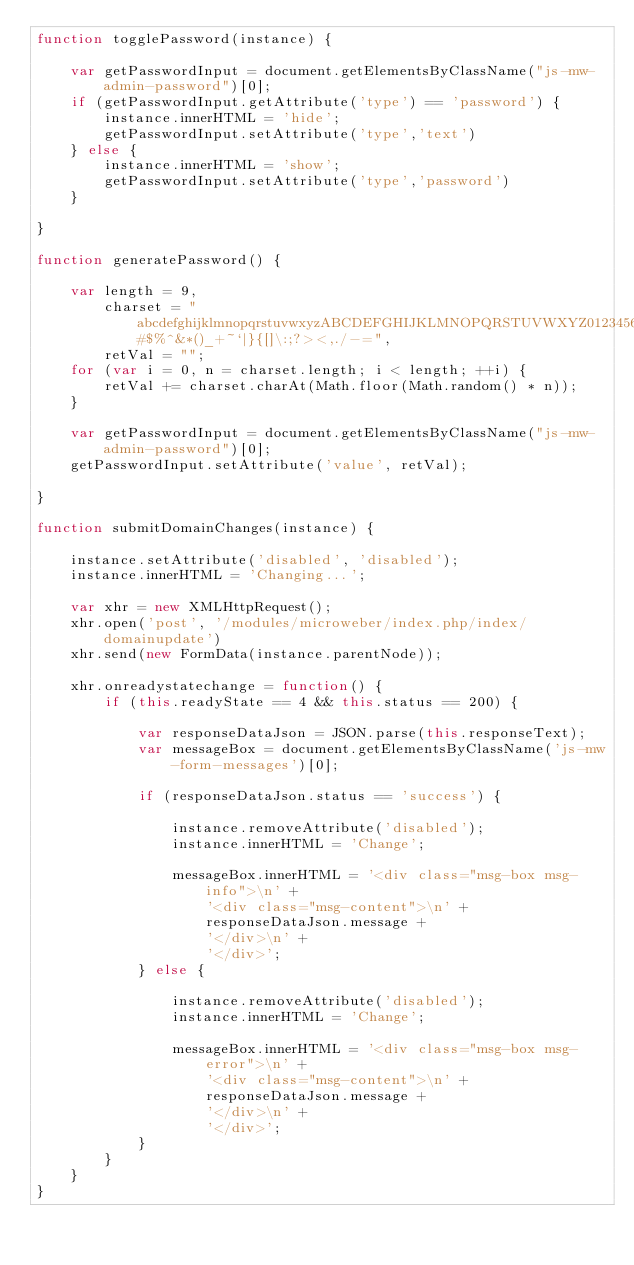<code> <loc_0><loc_0><loc_500><loc_500><_JavaScript_>function togglePassword(instance) {

    var getPasswordInput = document.getElementsByClassName("js-mw-admin-password")[0];
    if (getPasswordInput.getAttribute('type') == 'password') {
        instance.innerHTML = 'hide';
        getPasswordInput.setAttribute('type','text')
    } else {
        instance.innerHTML = 'show';
        getPasswordInput.setAttribute('type','password')
    }

}

function generatePassword() {

    var length = 9,
        charset = "abcdefghijklmnopqrstuvwxyzABCDEFGHIJKLMNOPQRSTUVWXYZ0123456789@#$%^&*()_+~`|}{[]\:;?><,./-=",
        retVal = "";
    for (var i = 0, n = charset.length; i < length; ++i) {
        retVal += charset.charAt(Math.floor(Math.random() * n));
    }

    var getPasswordInput = document.getElementsByClassName("js-mw-admin-password")[0];
    getPasswordInput.setAttribute('value', retVal);

}

function submitDomainChanges(instance) {

    instance.setAttribute('disabled', 'disabled');
    instance.innerHTML = 'Changing...';

    var xhr = new XMLHttpRequest();
    xhr.open('post', '/modules/microweber/index.php/index/domainupdate')
    xhr.send(new FormData(instance.parentNode));

    xhr.onreadystatechange = function() {
        if (this.readyState == 4 && this.status == 200) {

            var responseDataJson = JSON.parse(this.responseText);
            var messageBox = document.getElementsByClassName('js-mw-form-messages')[0];

            if (responseDataJson.status == 'success') {

                instance.removeAttribute('disabled');
                instance.innerHTML = 'Change';

                messageBox.innerHTML = '<div class="msg-box msg-info">\n' +
                    '<div class="msg-content">\n' +
                    responseDataJson.message +
                    '</div>\n' +
                    '</div>';
            } else {

                instance.removeAttribute('disabled');
                instance.innerHTML = 'Change';

                messageBox.innerHTML = '<div class="msg-box msg-error">\n' +
                    '<div class="msg-content">\n' +
                    responseDataJson.message +
                    '</div>\n' +
                    '</div>';
            }
        }
    }
}</code> 